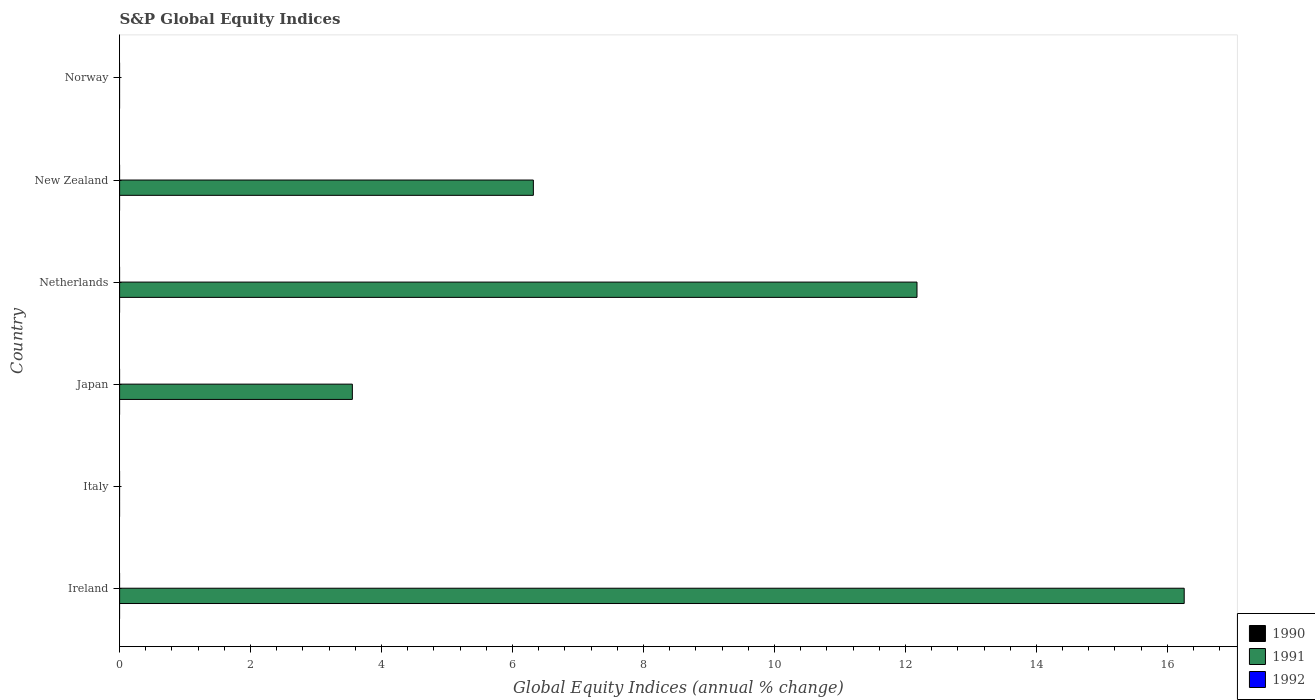How many different coloured bars are there?
Your response must be concise. 1. How many bars are there on the 5th tick from the bottom?
Provide a short and direct response. 1. What is the global equity indices in 1991 in Japan?
Your response must be concise. 3.55. Across all countries, what is the maximum global equity indices in 1991?
Offer a very short reply. 16.26. Across all countries, what is the minimum global equity indices in 1991?
Ensure brevity in your answer.  0. In which country was the global equity indices in 1991 maximum?
Your response must be concise. Ireland. What is the total global equity indices in 1991 in the graph?
Provide a succinct answer. 38.31. What is the difference between the global equity indices in 1991 in Netherlands and that in New Zealand?
Offer a terse response. 5.86. What is the difference between the global equity indices in 1991 in Japan and the global equity indices in 1990 in Norway?
Provide a short and direct response. 3.55. What is the difference between the highest and the second highest global equity indices in 1991?
Your answer should be compact. 4.08. What is the difference between the highest and the lowest global equity indices in 1991?
Provide a short and direct response. 16.26. In how many countries, is the global equity indices in 1990 greater than the average global equity indices in 1990 taken over all countries?
Keep it short and to the point. 0. Are all the bars in the graph horizontal?
Ensure brevity in your answer.  Yes. How many countries are there in the graph?
Keep it short and to the point. 6. What is the difference between two consecutive major ticks on the X-axis?
Provide a short and direct response. 2. Are the values on the major ticks of X-axis written in scientific E-notation?
Your answer should be compact. No. How many legend labels are there?
Make the answer very short. 3. How are the legend labels stacked?
Offer a terse response. Vertical. What is the title of the graph?
Your response must be concise. S&P Global Equity Indices. Does "1960" appear as one of the legend labels in the graph?
Provide a short and direct response. No. What is the label or title of the X-axis?
Make the answer very short. Global Equity Indices (annual % change). What is the Global Equity Indices (annual % change) in 1990 in Ireland?
Offer a very short reply. 0. What is the Global Equity Indices (annual % change) in 1991 in Ireland?
Your answer should be compact. 16.26. What is the Global Equity Indices (annual % change) of 1992 in Italy?
Your answer should be compact. 0. What is the Global Equity Indices (annual % change) in 1990 in Japan?
Provide a short and direct response. 0. What is the Global Equity Indices (annual % change) in 1991 in Japan?
Your answer should be compact. 3.55. What is the Global Equity Indices (annual % change) in 1992 in Japan?
Offer a very short reply. 0. What is the Global Equity Indices (annual % change) in 1990 in Netherlands?
Ensure brevity in your answer.  0. What is the Global Equity Indices (annual % change) in 1991 in Netherlands?
Offer a terse response. 12.18. What is the Global Equity Indices (annual % change) in 1990 in New Zealand?
Offer a terse response. 0. What is the Global Equity Indices (annual % change) in 1991 in New Zealand?
Ensure brevity in your answer.  6.32. What is the Global Equity Indices (annual % change) of 1992 in New Zealand?
Your answer should be compact. 0. What is the Global Equity Indices (annual % change) of 1992 in Norway?
Provide a succinct answer. 0. Across all countries, what is the maximum Global Equity Indices (annual % change) of 1991?
Ensure brevity in your answer.  16.26. What is the total Global Equity Indices (annual % change) in 1990 in the graph?
Offer a very short reply. 0. What is the total Global Equity Indices (annual % change) in 1991 in the graph?
Offer a terse response. 38.31. What is the total Global Equity Indices (annual % change) in 1992 in the graph?
Provide a short and direct response. 0. What is the difference between the Global Equity Indices (annual % change) of 1991 in Ireland and that in Japan?
Give a very brief answer. 12.7. What is the difference between the Global Equity Indices (annual % change) of 1991 in Ireland and that in Netherlands?
Your response must be concise. 4.08. What is the difference between the Global Equity Indices (annual % change) in 1991 in Ireland and that in New Zealand?
Keep it short and to the point. 9.94. What is the difference between the Global Equity Indices (annual % change) in 1991 in Japan and that in Netherlands?
Ensure brevity in your answer.  -8.62. What is the difference between the Global Equity Indices (annual % change) in 1991 in Japan and that in New Zealand?
Your answer should be compact. -2.76. What is the difference between the Global Equity Indices (annual % change) of 1991 in Netherlands and that in New Zealand?
Offer a very short reply. 5.86. What is the average Global Equity Indices (annual % change) of 1990 per country?
Offer a terse response. 0. What is the average Global Equity Indices (annual % change) in 1991 per country?
Ensure brevity in your answer.  6.38. What is the average Global Equity Indices (annual % change) in 1992 per country?
Your answer should be compact. 0. What is the ratio of the Global Equity Indices (annual % change) of 1991 in Ireland to that in Japan?
Ensure brevity in your answer.  4.57. What is the ratio of the Global Equity Indices (annual % change) of 1991 in Ireland to that in Netherlands?
Your response must be concise. 1.34. What is the ratio of the Global Equity Indices (annual % change) in 1991 in Ireland to that in New Zealand?
Your answer should be very brief. 2.57. What is the ratio of the Global Equity Indices (annual % change) in 1991 in Japan to that in Netherlands?
Provide a succinct answer. 0.29. What is the ratio of the Global Equity Indices (annual % change) of 1991 in Japan to that in New Zealand?
Make the answer very short. 0.56. What is the ratio of the Global Equity Indices (annual % change) of 1991 in Netherlands to that in New Zealand?
Provide a succinct answer. 1.93. What is the difference between the highest and the second highest Global Equity Indices (annual % change) of 1991?
Offer a very short reply. 4.08. What is the difference between the highest and the lowest Global Equity Indices (annual % change) of 1991?
Your answer should be very brief. 16.26. 